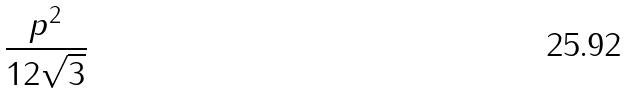Convert formula to latex. <formula><loc_0><loc_0><loc_500><loc_500>\frac { p ^ { 2 } } { 1 2 \sqrt { 3 } }</formula> 